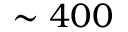Convert formula to latex. <formula><loc_0><loc_0><loc_500><loc_500>\sim 4 0 0</formula> 